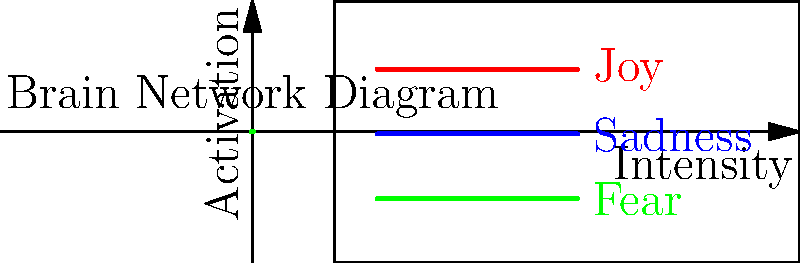In the brain network diagram representing different emotions, which emotion shows the highest peak activation? To determine which emotion shows the highest peak activation, we need to analyze the three curves representing different emotions:

1. Red curve (Joy): This curve has a bell-shaped appearance, typical of a Gaussian distribution. Its peak is the highest among all three curves, reaching approximately 0.5 on the vertical axis.

2. Blue curve (Sadness): This curve follows a sinusoidal pattern. Its peak is lower than the red curve, reaching about 0.3 on the vertical axis.

3. Green curve (Fear): This curve shows a cosine-like oscillation with a higher frequency than the blue curve. Its peak is the lowest among all three, reaching about 0.2 on the vertical axis.

By comparing the maximum height of each curve, we can conclude that the red curve, representing Joy, shows the highest peak activation.

This representation aligns with the concept of emotional intelligence for children, as it visually demonstrates how different emotions can vary in intensity and activation levels within the brain network.
Answer: Joy 